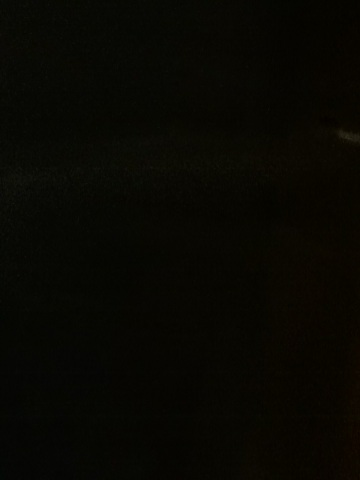Can you describe what could be causing the darkness in this image? The darkness in the image could be attributed to very low ambient light, or it could be a result of the camera's settings such as low exposure, a closed aperture, or a fast shutter speed that did not allow enough light to enter the lens. 